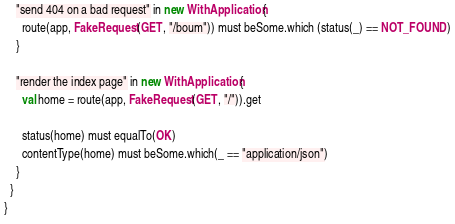<code> <loc_0><loc_0><loc_500><loc_500><_Scala_>    "send 404 on a bad request" in new WithApplication {
      route(app, FakeRequest(GET, "/boum")) must beSome.which (status(_) == NOT_FOUND)
    }

    "render the index page" in new WithApplication {
      val home = route(app, FakeRequest(GET, "/")).get

      status(home) must equalTo(OK)
      contentType(home) must beSome.which(_ == "application/json")
    }
  }
}
</code> 